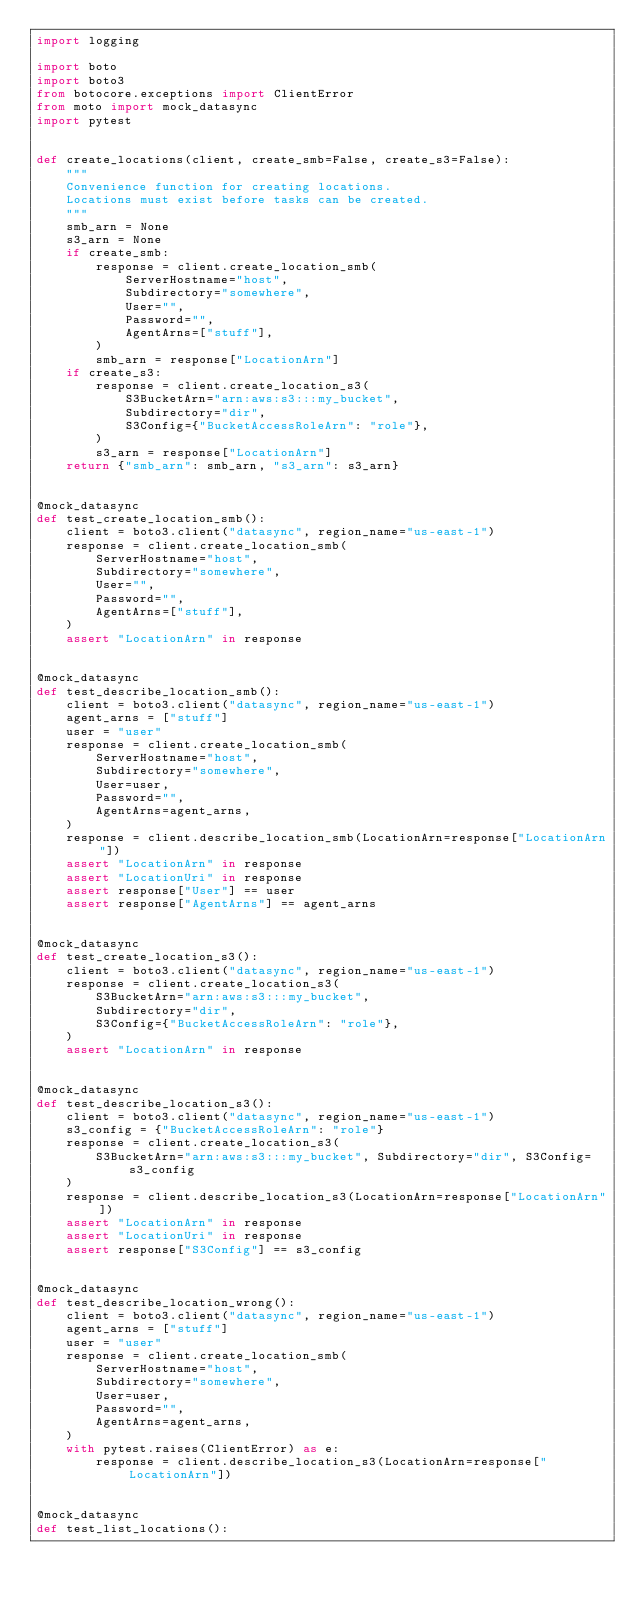Convert code to text. <code><loc_0><loc_0><loc_500><loc_500><_Python_>import logging

import boto
import boto3
from botocore.exceptions import ClientError
from moto import mock_datasync
import pytest


def create_locations(client, create_smb=False, create_s3=False):
    """
    Convenience function for creating locations.
    Locations must exist before tasks can be created.
    """
    smb_arn = None
    s3_arn = None
    if create_smb:
        response = client.create_location_smb(
            ServerHostname="host",
            Subdirectory="somewhere",
            User="",
            Password="",
            AgentArns=["stuff"],
        )
        smb_arn = response["LocationArn"]
    if create_s3:
        response = client.create_location_s3(
            S3BucketArn="arn:aws:s3:::my_bucket",
            Subdirectory="dir",
            S3Config={"BucketAccessRoleArn": "role"},
        )
        s3_arn = response["LocationArn"]
    return {"smb_arn": smb_arn, "s3_arn": s3_arn}


@mock_datasync
def test_create_location_smb():
    client = boto3.client("datasync", region_name="us-east-1")
    response = client.create_location_smb(
        ServerHostname="host",
        Subdirectory="somewhere",
        User="",
        Password="",
        AgentArns=["stuff"],
    )
    assert "LocationArn" in response


@mock_datasync
def test_describe_location_smb():
    client = boto3.client("datasync", region_name="us-east-1")
    agent_arns = ["stuff"]
    user = "user"
    response = client.create_location_smb(
        ServerHostname="host",
        Subdirectory="somewhere",
        User=user,
        Password="",
        AgentArns=agent_arns,
    )
    response = client.describe_location_smb(LocationArn=response["LocationArn"])
    assert "LocationArn" in response
    assert "LocationUri" in response
    assert response["User"] == user
    assert response["AgentArns"] == agent_arns


@mock_datasync
def test_create_location_s3():
    client = boto3.client("datasync", region_name="us-east-1")
    response = client.create_location_s3(
        S3BucketArn="arn:aws:s3:::my_bucket",
        Subdirectory="dir",
        S3Config={"BucketAccessRoleArn": "role"},
    )
    assert "LocationArn" in response


@mock_datasync
def test_describe_location_s3():
    client = boto3.client("datasync", region_name="us-east-1")
    s3_config = {"BucketAccessRoleArn": "role"}
    response = client.create_location_s3(
        S3BucketArn="arn:aws:s3:::my_bucket", Subdirectory="dir", S3Config=s3_config
    )
    response = client.describe_location_s3(LocationArn=response["LocationArn"])
    assert "LocationArn" in response
    assert "LocationUri" in response
    assert response["S3Config"] == s3_config


@mock_datasync
def test_describe_location_wrong():
    client = boto3.client("datasync", region_name="us-east-1")
    agent_arns = ["stuff"]
    user = "user"
    response = client.create_location_smb(
        ServerHostname="host",
        Subdirectory="somewhere",
        User=user,
        Password="",
        AgentArns=agent_arns,
    )
    with pytest.raises(ClientError) as e:
        response = client.describe_location_s3(LocationArn=response["LocationArn"])


@mock_datasync
def test_list_locations():</code> 